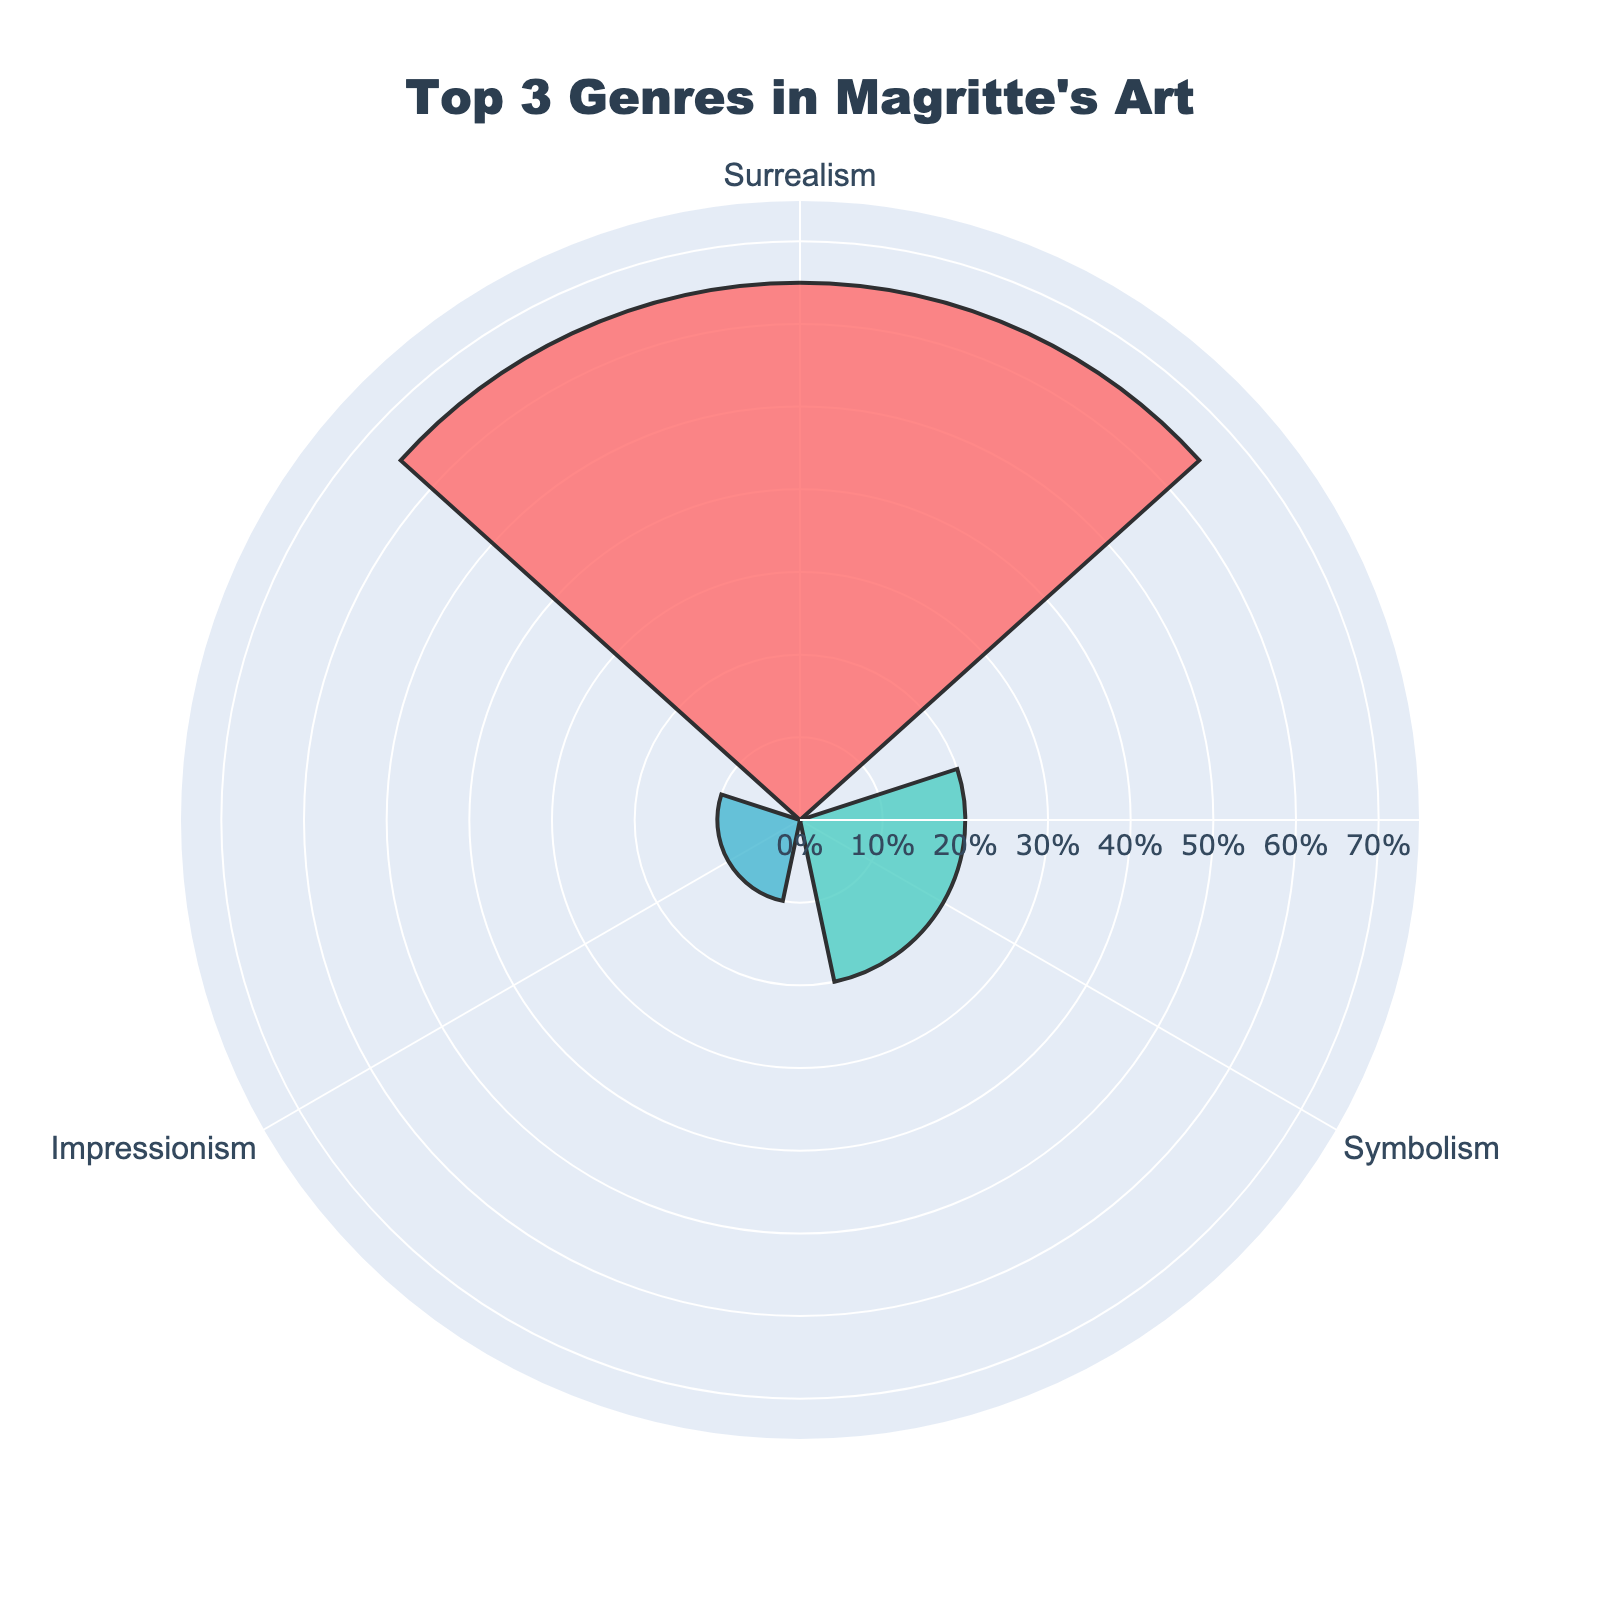What is the title of the rose chart? The title of the rose chart is displayed prominently at the top.
Answer: Top 3 Genres in Magritte's Art Which genre has the highest percentage in Magritte's art collection? The genre with the highest percentage is represented by the largest bar and is positioned first.
Answer: Surrealism What are the colors used for the different genres? Observing the bars, we see different colors assigned to each genre from top to bottom: pink, mint green, and sky blue.
Answer: Pink, mint green, sky blue What's the combined percentage for the top 3 genres in Magritte's collection? Adding the percentages of the top three genres: 65% (Surrealism) + 20% (Symbolism) + 10% (Impressionism).
Answer: 95% Which genre has the smallest percentage among the top 3? The smallest percentage will be represented by the shortest bar among the three genres shown.
Answer: Impressionism How much larger is Surrealism's percentage compared to Symbolism's? Subtract the percentage of Symbolism from that of Surrealism: 65% - 20%.
Answer: 45% If a fourth genre were to be included, what would its name and percentage be? Looking at the original data, the fourth genre is the one not included in the current top 3.
Answer: Cubism, 5% What is the average percentage of the top three genres in Magritte's art collection? Sum the percentages of the top three genres and divide by 3: (65% + 20% + 10%) / 3.
Answer: 31.67% How is the radial axis labeled in the rose chart? The radial axis shows percentages with tick marks and suffixes indicating percentages.
Answer: Percentages with '%' labels Which direction does the angular axis rotate in the rose chart? The angular axis label rotation direction is indicated in the layout details as clockwise.
Answer: Clockwise 